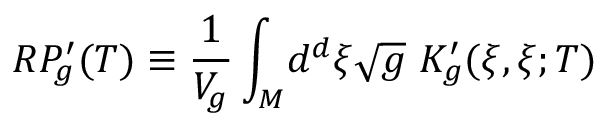<formula> <loc_0><loc_0><loc_500><loc_500>R P _ { g } ^ { \prime } ( T ) \equiv \frac { 1 } { V _ { g } } \int _ { M } \, d ^ { d } \xi \sqrt { g } \ K _ { g } ^ { \prime } ( \xi , \xi ; T )</formula> 